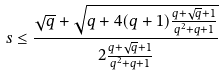Convert formula to latex. <formula><loc_0><loc_0><loc_500><loc_500>s \leq \frac { \sqrt { q } + \sqrt { q + 4 ( q + 1 ) \frac { q + \sqrt { q } + 1 } { q ^ { 2 } + q + 1 } } } { 2 \frac { q + \sqrt { q } + 1 } { q ^ { 2 } + q + 1 } }</formula> 